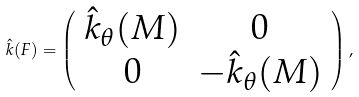Convert formula to latex. <formula><loc_0><loc_0><loc_500><loc_500>\hat { k } ( F ) = \left ( \begin{array} { c c } \hat { k } _ { \theta } ( M ) & 0 \\ 0 & - \hat { k } _ { \theta } ( M ) \\ \end{array} \right ) ,</formula> 